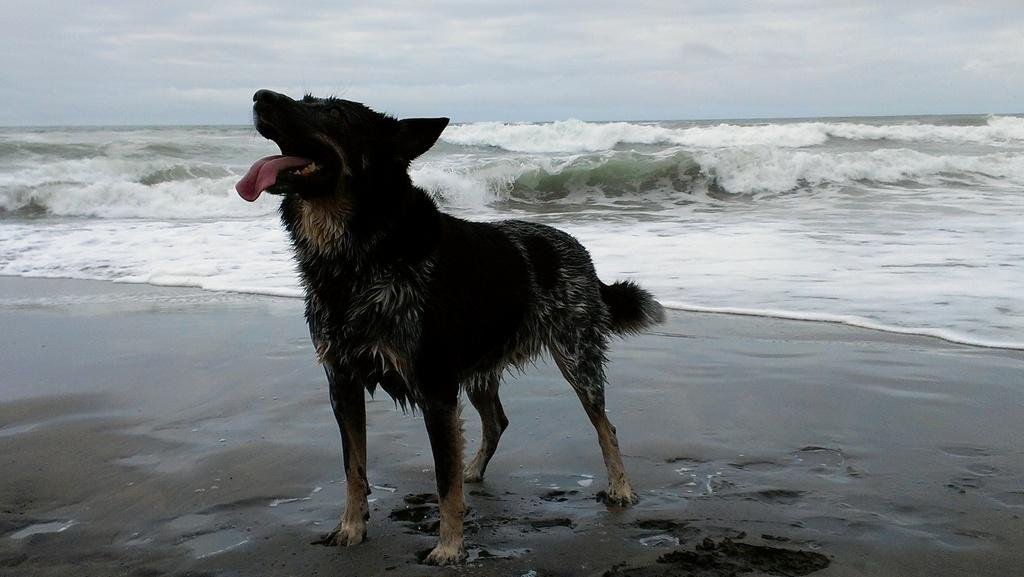What animal can be seen in the image? There is a dog in the image. Where is the dog located? The dog is standing on the seashore. What can be seen behind the dog? There are waves visible behind the dog. What is visible at the top of the image? The sky is visible at the top of the image. What can be observed in the sky? Clouds are present in the sky. What type of trouble is the dog causing in the image? There is no indication of trouble or any specific behavior in the image; the dog is simply standing on the seashore. 